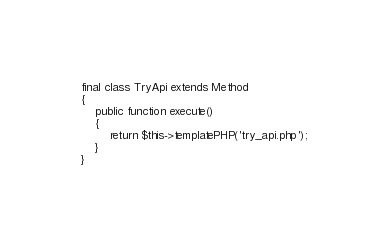<code> <loc_0><loc_0><loc_500><loc_500><_PHP_>
final class TryApi extends Method
{
    public function execute()
    {
        return $this->templatePHP('try_api.php');
    }
}</code> 